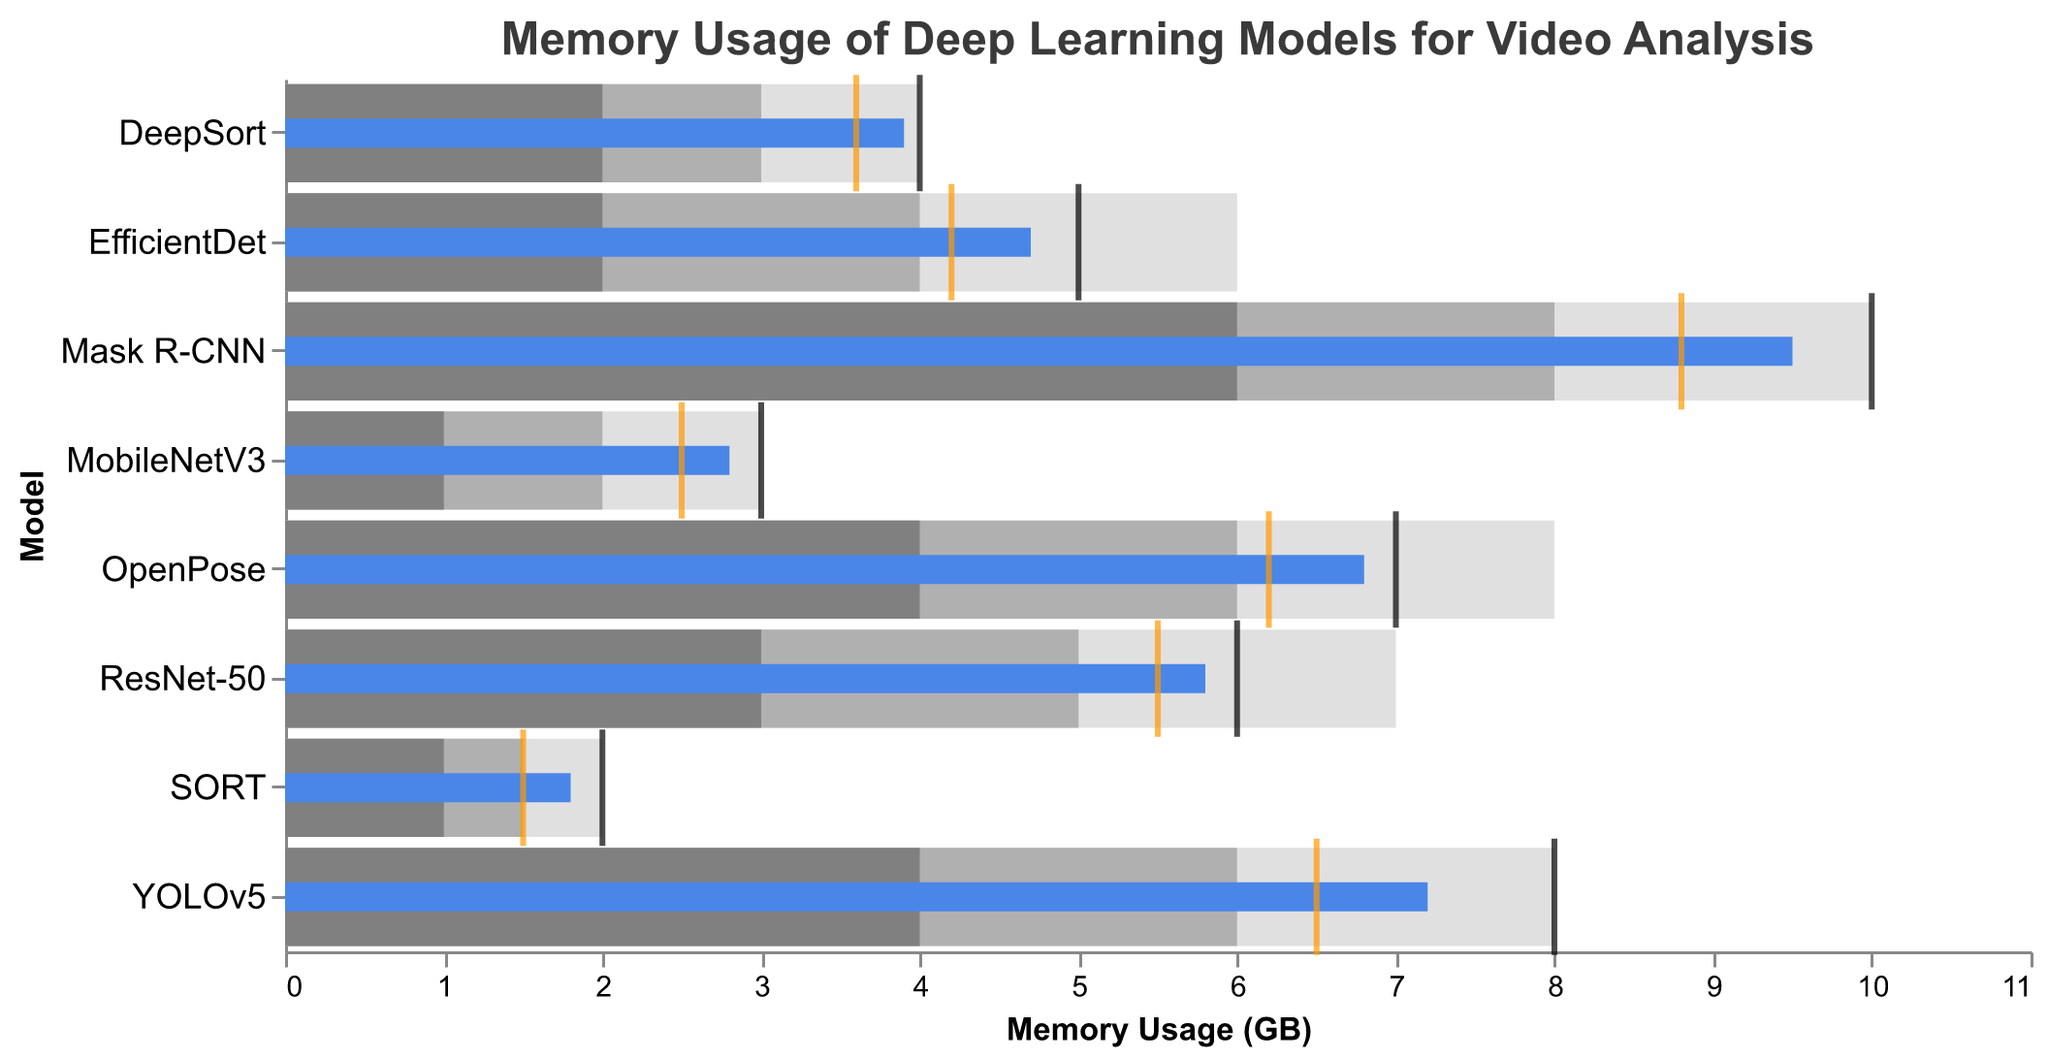What is the title of the figure? The title can be found at the top of the figure and it describes the main purpose of the chart. By looking there, you can see the title "Memory Usage of Deep Learning Models for Video Analysis".
Answer: Memory Usage of Deep Learning Models for Video Analysis Which model has the highest target memory usage? By looking at the tick marks representing target values, Mask R-CNN has the highest target value indicated at point 10.
Answer: Mask R-CNN What is the actual memory usage of the MobileNetV3 model? Locate the bar corresponding to MobileNetV3 and identify the smaller bar representing actual usage, which aligns with the value 2.8.
Answer: 2.8 How does the comparative memory usage of EfficientDet compare to its actual memory usage? The comparative memory usage tick (orange) for EfficientDet is at 4.2, while the actual usage bar is at 4.7, indicating the comparative is slightly lower.
Answer: Comparative is lower Which model has the closest actual memory usage to its target? By comparing the actual and target memory usage bars and ticks, YOLOv5 has actual memory usage (7.2) closest to its target (8).
Answer: YOLOv5 Summarize the range categories for the OpenPose model. The range categories for OpenPose are represented by three shades of grey behind its bar: Range1 (4), Range2 (6), and Range3 (8).
Answer: 4, 6, 8 Compare the actual memory usage between YOLOv5 and ResNet-50. Which one is higher? Look at the bars representing actual memory usage for YOLOv5 and ResNet-50. YOLOv5 is at 7.2, while ResNet-50 is at 5.8. Therefore, YOLOv5 is higher.
Answer: YOLOv5 Identify all models with actual memory usage within the Range2 category. Look at the models and their bar values, and see which models' actual usage falls within the middle grey category (Range2). These models are YOLOv5 (7.2), OpenPose (6.8), ResNet-50 (5.8), EfficientDet (4.7), and DeepSort (3.9).
Answer: YOLOv5, OpenPose, ResNet-50, EfficientDet, DeepSort 